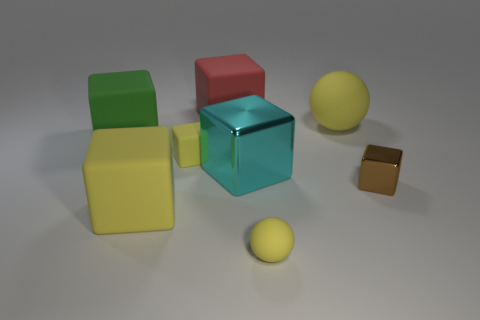Subtract all big green matte cubes. How many cubes are left? 5 Add 2 yellow rubber spheres. How many objects exist? 10 Subtract all blocks. How many objects are left? 2 Subtract 4 blocks. How many blocks are left? 2 Subtract all brown cubes. How many cubes are left? 5 Subtract all brown cylinders. How many yellow blocks are left? 2 Subtract 0 brown cylinders. How many objects are left? 8 Subtract all red balls. Subtract all brown cubes. How many balls are left? 2 Subtract all large metal blocks. Subtract all yellow spheres. How many objects are left? 5 Add 4 rubber balls. How many rubber balls are left? 6 